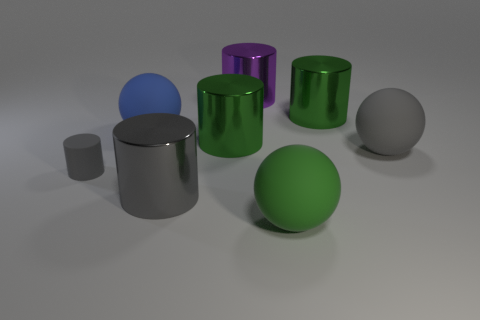Subtract 2 cylinders. How many cylinders are left? 3 Subtract all purple cylinders. How many cylinders are left? 4 Subtract all tiny cylinders. How many cylinders are left? 4 Add 1 gray matte spheres. How many objects exist? 9 Subtract all yellow cylinders. Subtract all blue cubes. How many cylinders are left? 5 Subtract all spheres. How many objects are left? 5 Add 1 large green cylinders. How many large green cylinders exist? 3 Subtract 0 gray cubes. How many objects are left? 8 Subtract all balls. Subtract all blue rubber spheres. How many objects are left? 4 Add 5 gray metallic things. How many gray metallic things are left? 6 